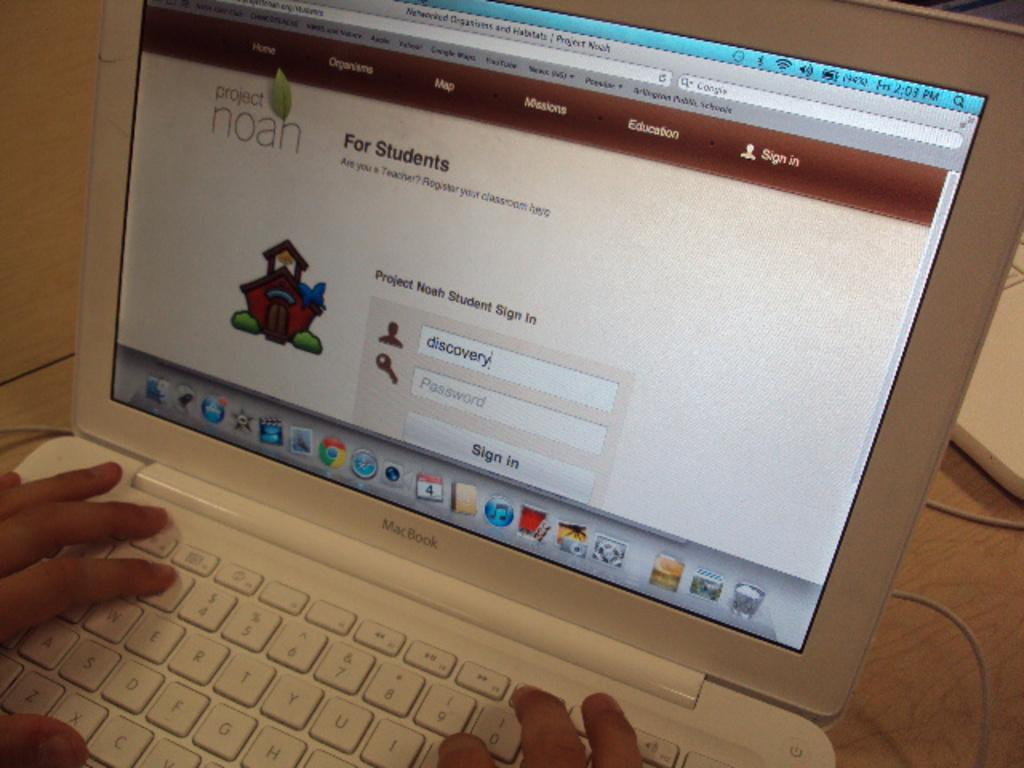<image>
Give a short and clear explanation of the subsequent image. Person using a Macbook with a screen saying "For Students". 